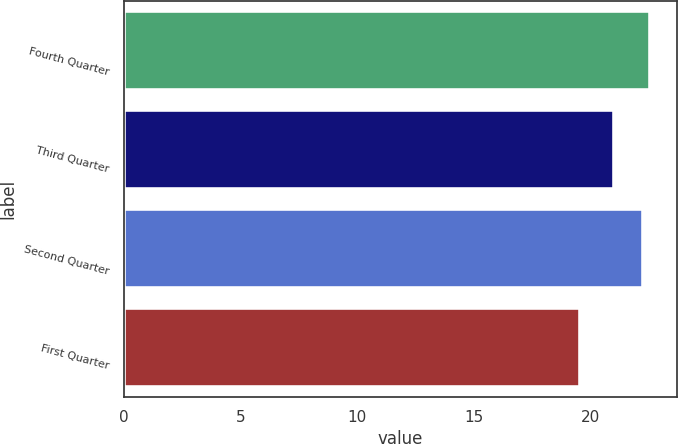Convert chart to OTSL. <chart><loc_0><loc_0><loc_500><loc_500><bar_chart><fcel>Fourth Quarter<fcel>Third Quarter<fcel>Second Quarter<fcel>First Quarter<nl><fcel>22.55<fcel>21.01<fcel>22.22<fcel>19.56<nl></chart> 